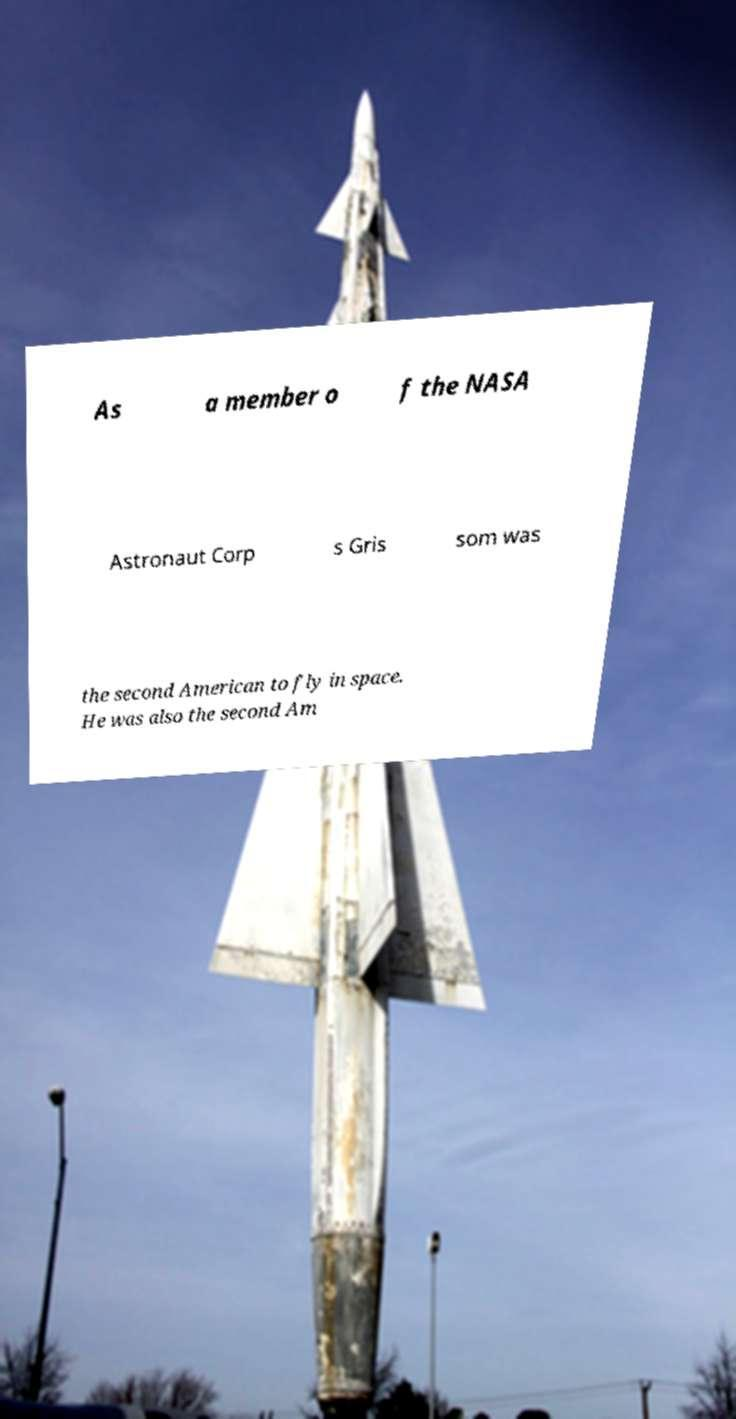Can you accurately transcribe the text from the provided image for me? As a member o f the NASA Astronaut Corp s Gris som was the second American to fly in space. He was also the second Am 